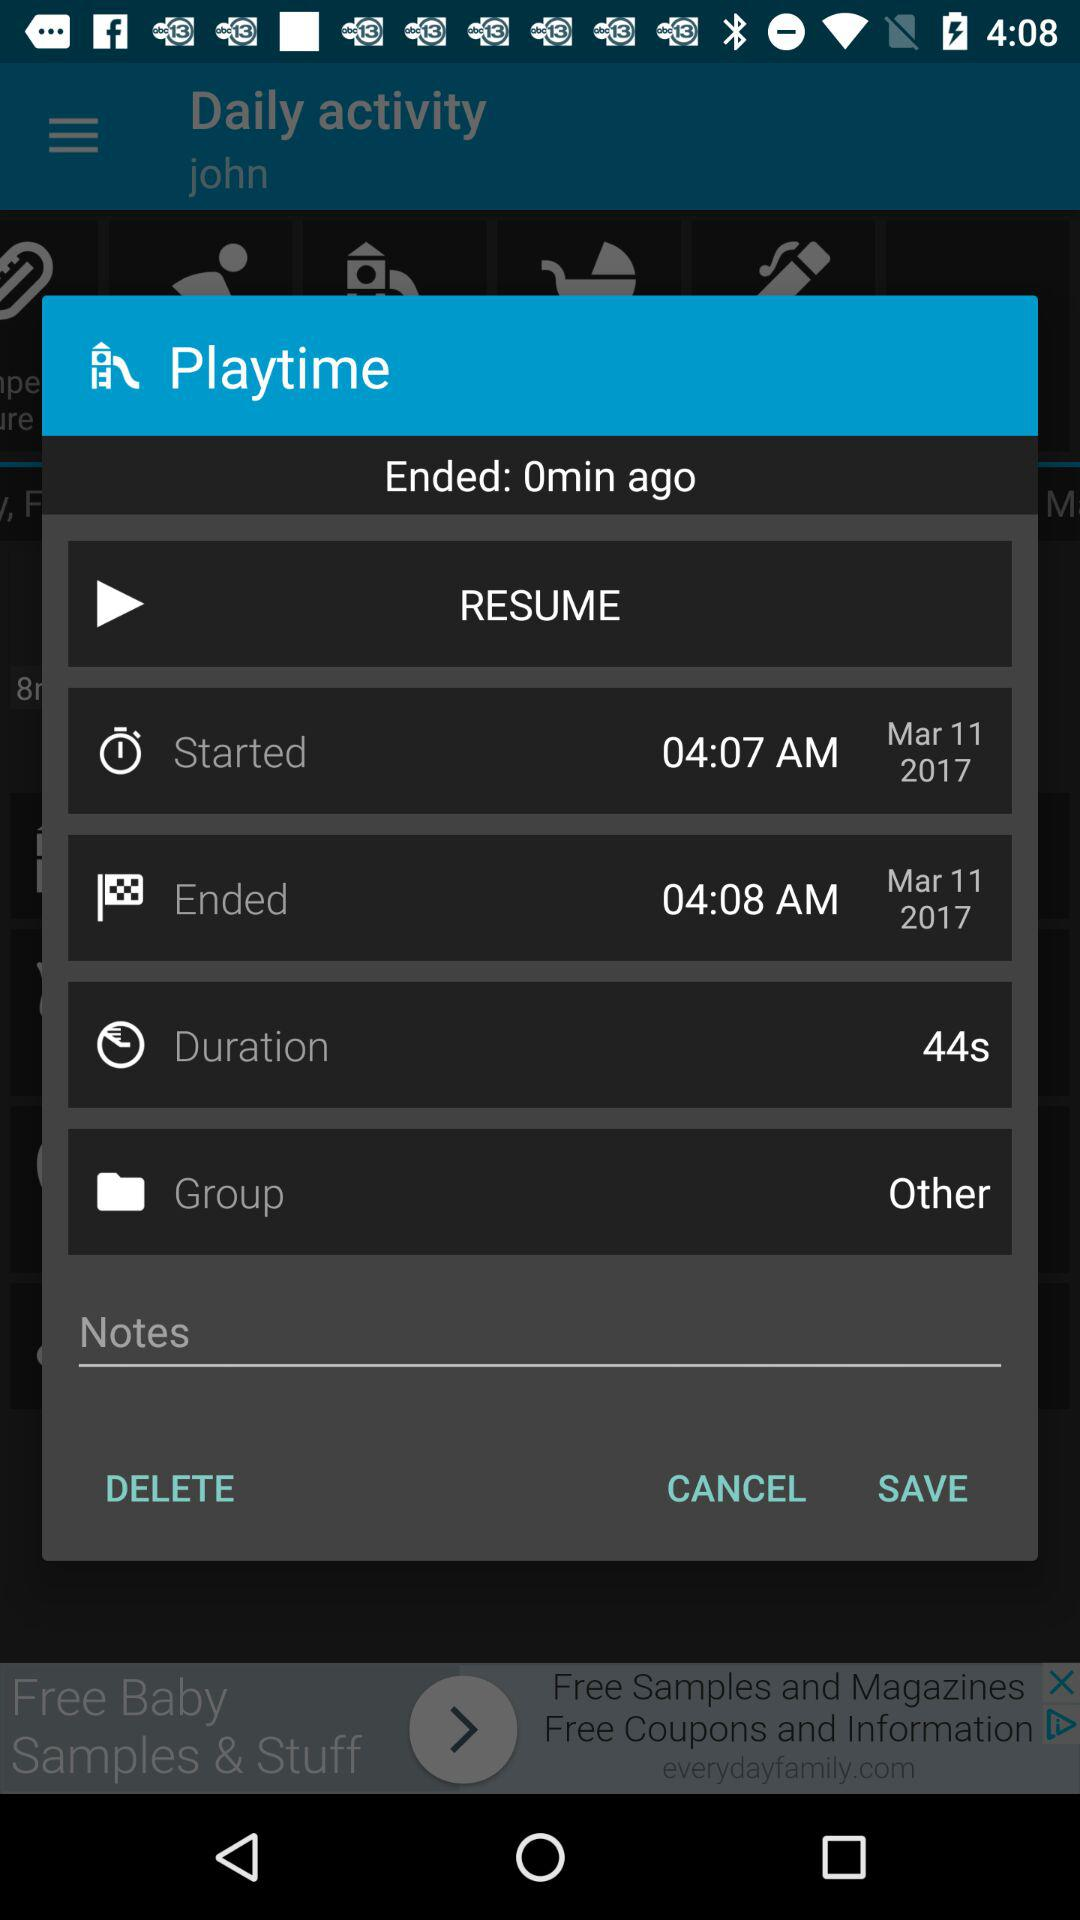What is the group? The group is "Other". 